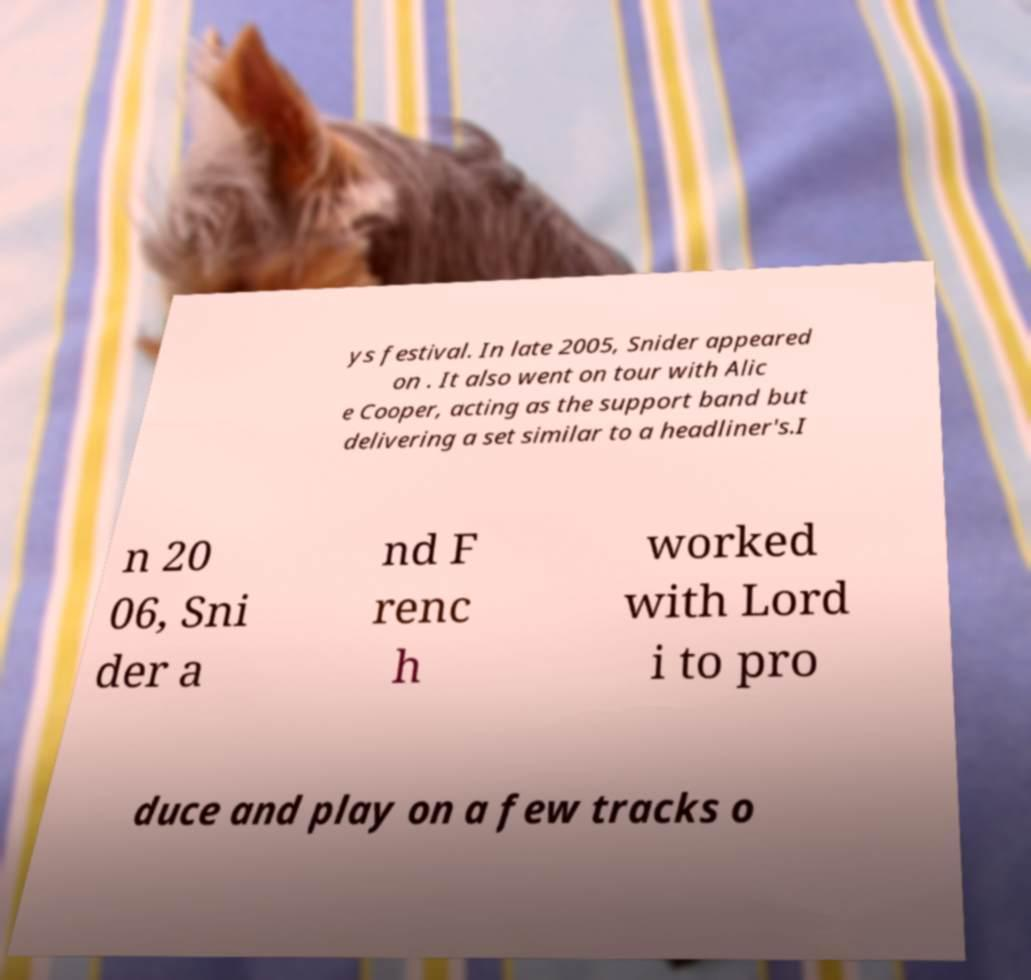For documentation purposes, I need the text within this image transcribed. Could you provide that? ys festival. In late 2005, Snider appeared on . It also went on tour with Alic e Cooper, acting as the support band but delivering a set similar to a headliner's.I n 20 06, Sni der a nd F renc h worked with Lord i to pro duce and play on a few tracks o 